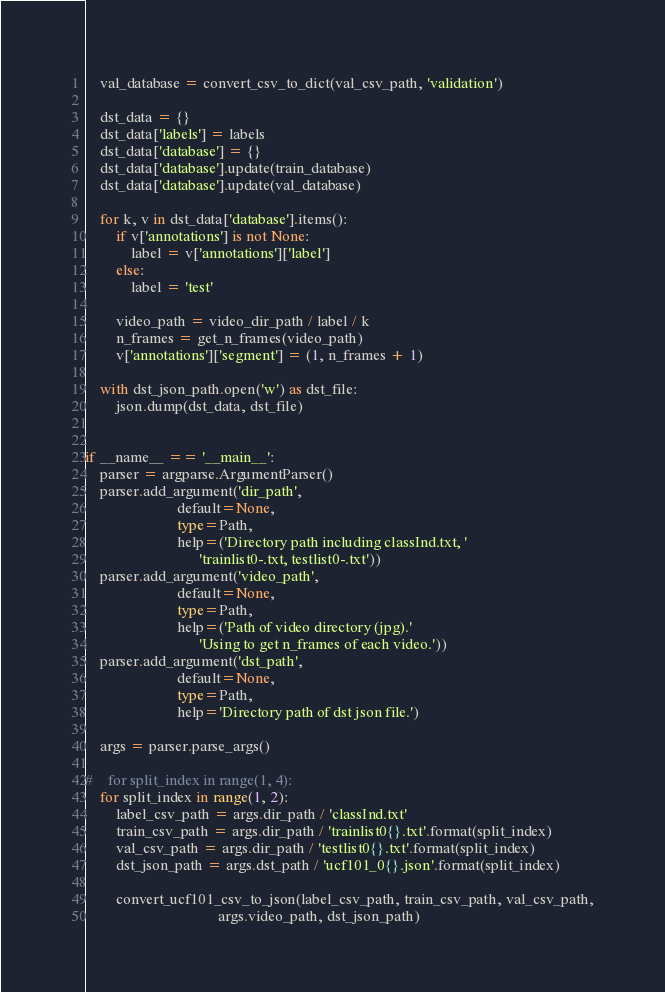Convert code to text. <code><loc_0><loc_0><loc_500><loc_500><_Python_>    val_database = convert_csv_to_dict(val_csv_path, 'validation')

    dst_data = {}
    dst_data['labels'] = labels
    dst_data['database'] = {}
    dst_data['database'].update(train_database)
    dst_data['database'].update(val_database)

    for k, v in dst_data['database'].items():
        if v['annotations'] is not None:
            label = v['annotations']['label']
        else:
            label = 'test'

        video_path = video_dir_path / label / k
        n_frames = get_n_frames(video_path)
        v['annotations']['segment'] = (1, n_frames + 1)

    with dst_json_path.open('w') as dst_file:
        json.dump(dst_data, dst_file)


if __name__ == '__main__':
    parser = argparse.ArgumentParser()
    parser.add_argument('dir_path',
                        default=None,
                        type=Path,
                        help=('Directory path including classInd.txt, '
                              'trainlist0-.txt, testlist0-.txt'))
    parser.add_argument('video_path',
                        default=None,
                        type=Path,
                        help=('Path of video directory (jpg).'
                              'Using to get n_frames of each video.'))
    parser.add_argument('dst_path',
                        default=None,
                        type=Path,
                        help='Directory path of dst json file.')

    args = parser.parse_args()

#    for split_index in range(1, 4):
    for split_index in range(1, 2):
        label_csv_path = args.dir_path / 'classInd.txt'
        train_csv_path = args.dir_path / 'trainlist0{}.txt'.format(split_index)
        val_csv_path = args.dir_path / 'testlist0{}.txt'.format(split_index)
        dst_json_path = args.dst_path / 'ucf101_0{}.json'.format(split_index)

        convert_ucf101_csv_to_json(label_csv_path, train_csv_path, val_csv_path,
                                   args.video_path, dst_json_path)
</code> 